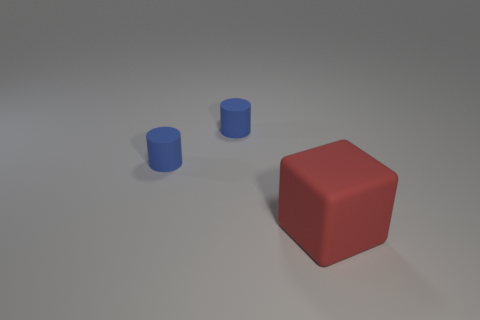What material is the big red object?
Make the answer very short. Rubber. Is there any other thing that is the same size as the block?
Give a very brief answer. No. How many other things are the same shape as the red thing?
Make the answer very short. 0. The big object is what shape?
Offer a very short reply. Cube. The large matte cube is what color?
Your answer should be very brief. Red. What number of metal objects are tiny cylinders or large blocks?
Your answer should be compact. 0. Is there another red rubber object that has the same size as the red matte object?
Provide a short and direct response. No. Is the number of small things that are behind the big matte thing greater than the number of matte blocks?
Your answer should be compact. Yes. How many large things are gray shiny spheres or matte cylinders?
Offer a terse response. 0. How many small things are the same shape as the large red object?
Provide a succinct answer. 0. 